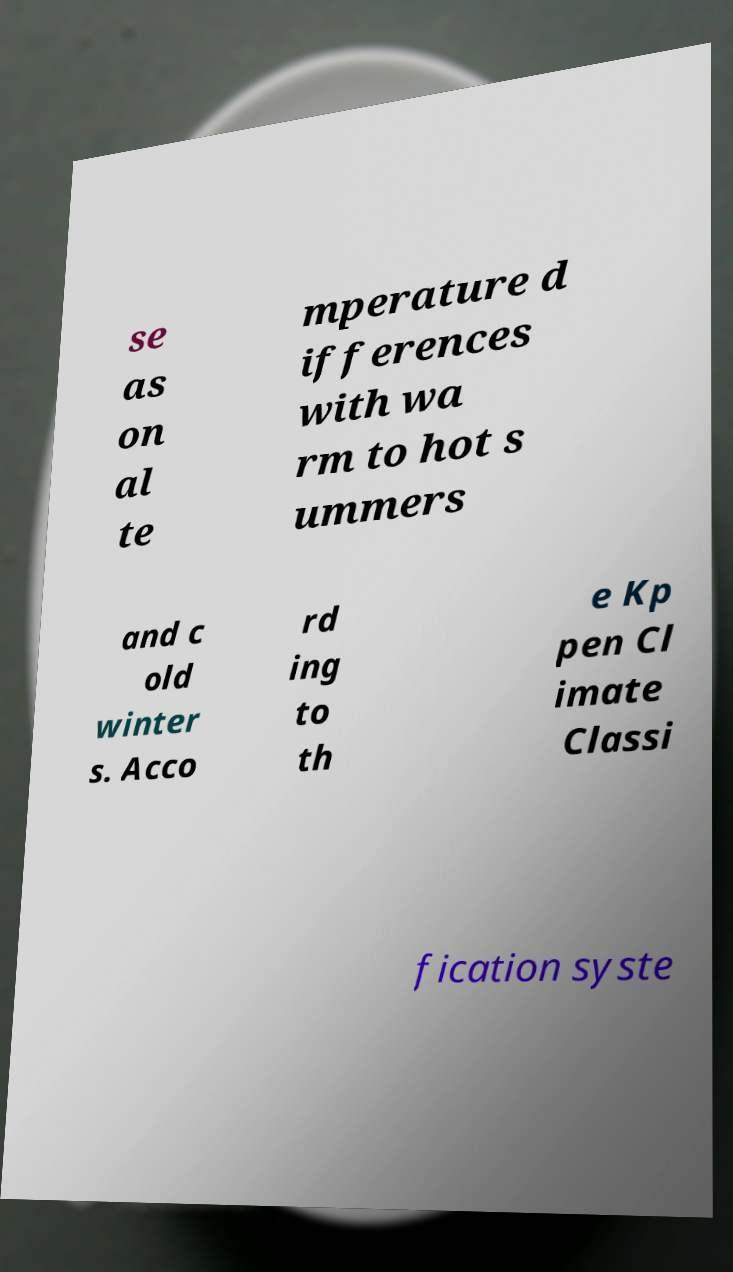Please read and relay the text visible in this image. What does it say? se as on al te mperature d ifferences with wa rm to hot s ummers and c old winter s. Acco rd ing to th e Kp pen Cl imate Classi fication syste 